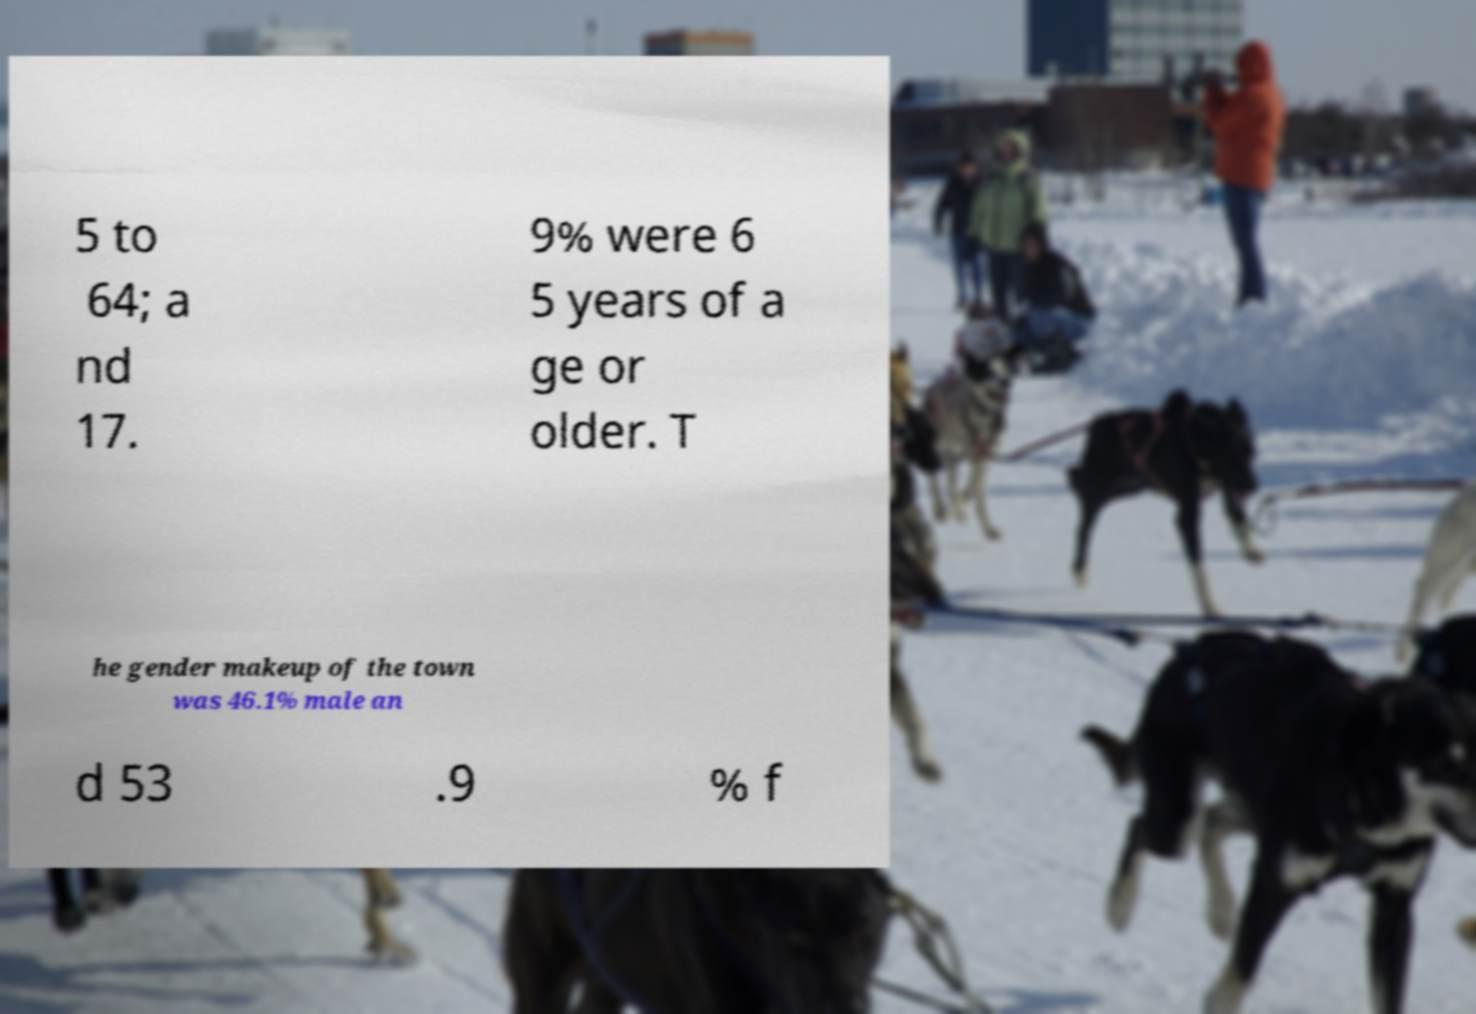For documentation purposes, I need the text within this image transcribed. Could you provide that? 5 to 64; a nd 17. 9% were 6 5 years of a ge or older. T he gender makeup of the town was 46.1% male an d 53 .9 % f 